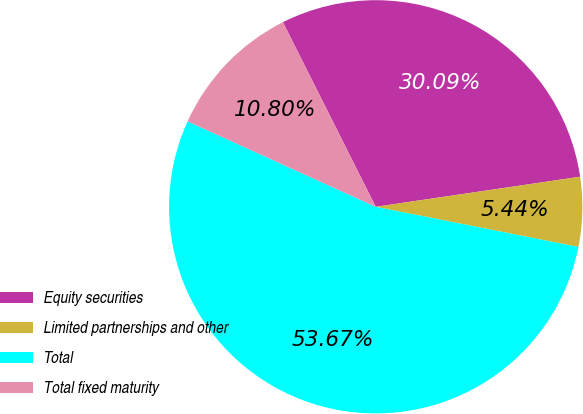Convert chart to OTSL. <chart><loc_0><loc_0><loc_500><loc_500><pie_chart><fcel>Equity securities<fcel>Limited partnerships and other<fcel>Total<fcel>Total fixed maturity<nl><fcel>30.09%<fcel>5.44%<fcel>53.67%<fcel>10.8%<nl></chart> 